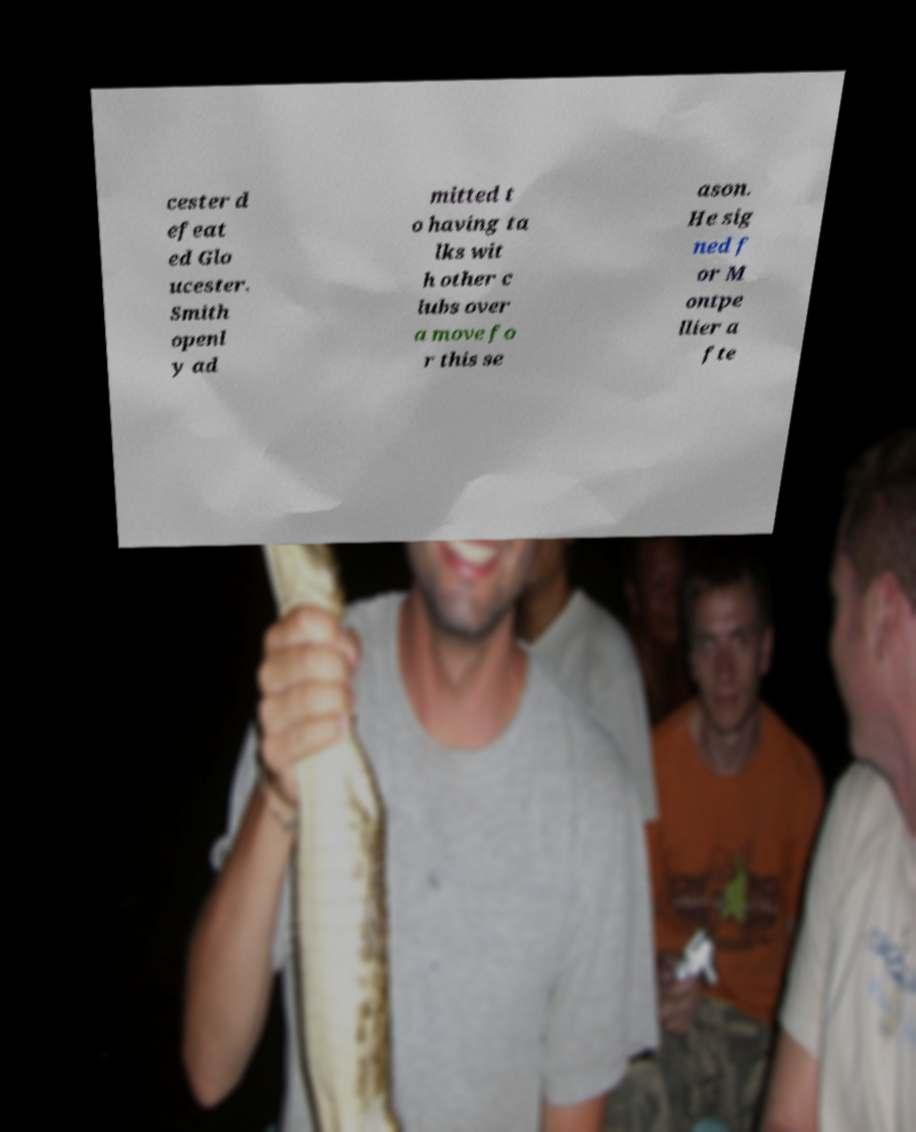Can you read and provide the text displayed in the image?This photo seems to have some interesting text. Can you extract and type it out for me? cester d efeat ed Glo ucester. Smith openl y ad mitted t o having ta lks wit h other c lubs over a move fo r this se ason. He sig ned f or M ontpe llier a fte 